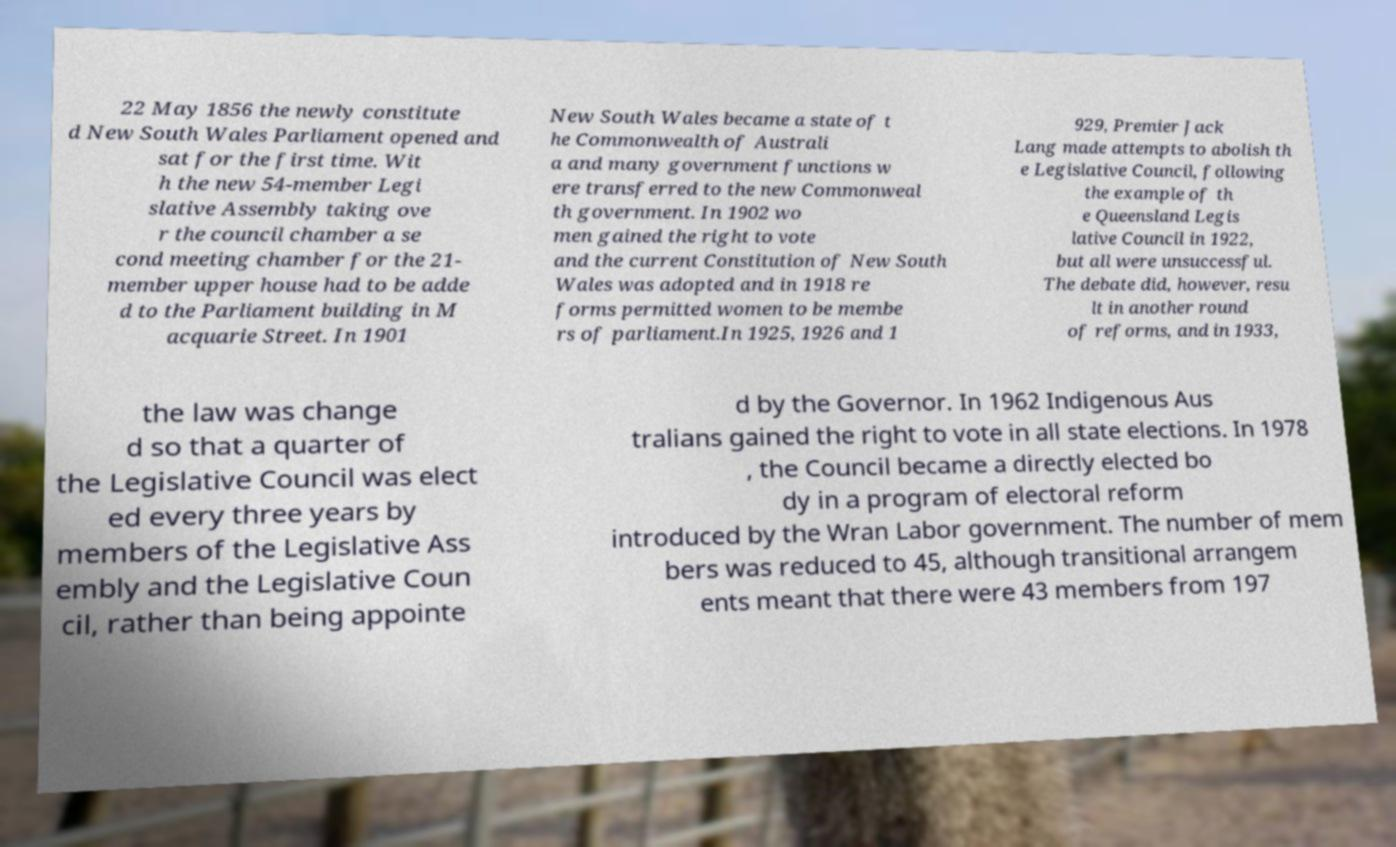I need the written content from this picture converted into text. Can you do that? 22 May 1856 the newly constitute d New South Wales Parliament opened and sat for the first time. Wit h the new 54-member Legi slative Assembly taking ove r the council chamber a se cond meeting chamber for the 21- member upper house had to be adde d to the Parliament building in M acquarie Street. In 1901 New South Wales became a state of t he Commonwealth of Australi a and many government functions w ere transferred to the new Commonweal th government. In 1902 wo men gained the right to vote and the current Constitution of New South Wales was adopted and in 1918 re forms permitted women to be membe rs of parliament.In 1925, 1926 and 1 929, Premier Jack Lang made attempts to abolish th e Legislative Council, following the example of th e Queensland Legis lative Council in 1922, but all were unsuccessful. The debate did, however, resu lt in another round of reforms, and in 1933, the law was change d so that a quarter of the Legislative Council was elect ed every three years by members of the Legislative Ass embly and the Legislative Coun cil, rather than being appointe d by the Governor. In 1962 Indigenous Aus tralians gained the right to vote in all state elections. In 1978 , the Council became a directly elected bo dy in a program of electoral reform introduced by the Wran Labor government. The number of mem bers was reduced to 45, although transitional arrangem ents meant that there were 43 members from 197 